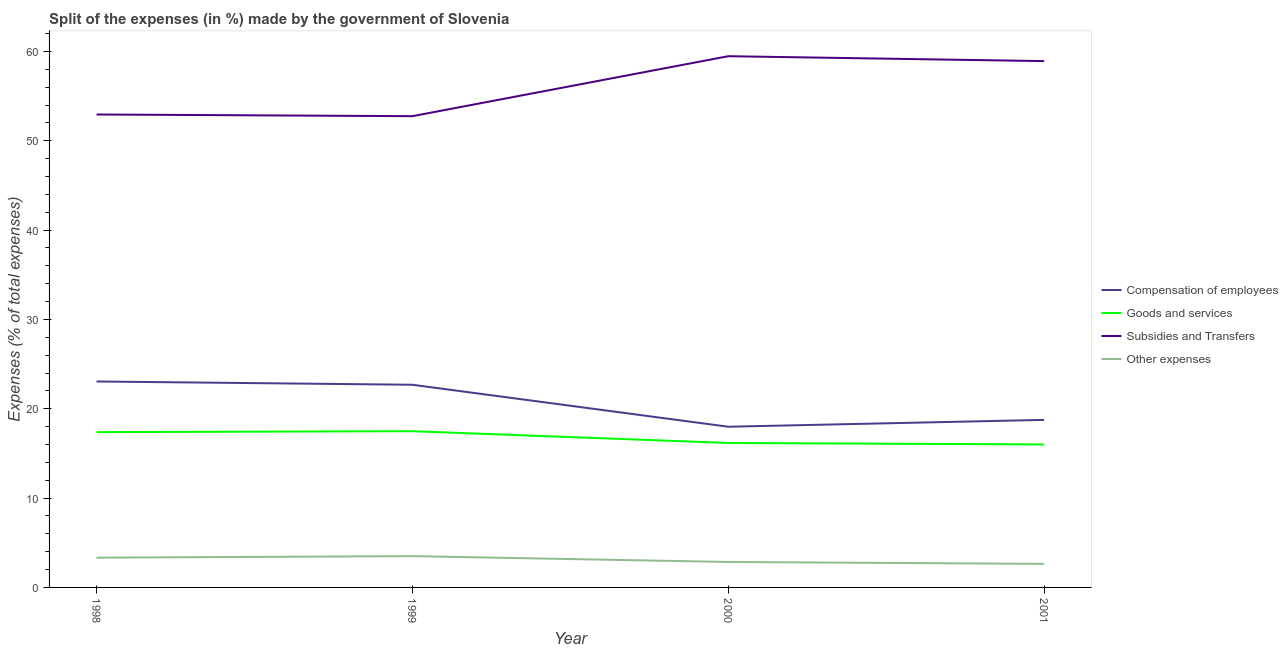How many different coloured lines are there?
Offer a very short reply. 4. Does the line corresponding to percentage of amount spent on goods and services intersect with the line corresponding to percentage of amount spent on other expenses?
Give a very brief answer. No. Is the number of lines equal to the number of legend labels?
Provide a short and direct response. Yes. What is the percentage of amount spent on subsidies in 2000?
Ensure brevity in your answer.  59.47. Across all years, what is the maximum percentage of amount spent on other expenses?
Your response must be concise. 3.5. Across all years, what is the minimum percentage of amount spent on other expenses?
Ensure brevity in your answer.  2.64. In which year was the percentage of amount spent on other expenses maximum?
Make the answer very short. 1999. In which year was the percentage of amount spent on compensation of employees minimum?
Offer a terse response. 2000. What is the total percentage of amount spent on other expenses in the graph?
Give a very brief answer. 12.32. What is the difference between the percentage of amount spent on subsidies in 1998 and that in 2000?
Provide a short and direct response. -6.52. What is the difference between the percentage of amount spent on goods and services in 2001 and the percentage of amount spent on subsidies in 1998?
Give a very brief answer. -36.94. What is the average percentage of amount spent on goods and services per year?
Offer a terse response. 16.76. In the year 2000, what is the difference between the percentage of amount spent on goods and services and percentage of amount spent on other expenses?
Provide a short and direct response. 13.32. What is the ratio of the percentage of amount spent on goods and services in 1998 to that in 2001?
Ensure brevity in your answer.  1.09. Is the percentage of amount spent on subsidies in 1999 less than that in 2000?
Ensure brevity in your answer.  Yes. What is the difference between the highest and the second highest percentage of amount spent on other expenses?
Your answer should be compact. 0.17. What is the difference between the highest and the lowest percentage of amount spent on goods and services?
Your answer should be very brief. 1.49. Is it the case that in every year, the sum of the percentage of amount spent on other expenses and percentage of amount spent on goods and services is greater than the sum of percentage of amount spent on compensation of employees and percentage of amount spent on subsidies?
Your answer should be compact. No. Is the percentage of amount spent on other expenses strictly greater than the percentage of amount spent on goods and services over the years?
Ensure brevity in your answer.  No. Is the percentage of amount spent on goods and services strictly less than the percentage of amount spent on subsidies over the years?
Your answer should be very brief. Yes. How many lines are there?
Give a very brief answer. 4. How many years are there in the graph?
Make the answer very short. 4. Does the graph contain any zero values?
Make the answer very short. No. Where does the legend appear in the graph?
Your answer should be very brief. Center right. How many legend labels are there?
Provide a succinct answer. 4. What is the title of the graph?
Your response must be concise. Split of the expenses (in %) made by the government of Slovenia. Does "France" appear as one of the legend labels in the graph?
Offer a very short reply. No. What is the label or title of the Y-axis?
Keep it short and to the point. Expenses (% of total expenses). What is the Expenses (% of total expenses) of Compensation of employees in 1998?
Make the answer very short. 23.05. What is the Expenses (% of total expenses) in Goods and services in 1998?
Give a very brief answer. 17.38. What is the Expenses (% of total expenses) in Subsidies and Transfers in 1998?
Offer a very short reply. 52.94. What is the Expenses (% of total expenses) in Other expenses in 1998?
Your answer should be very brief. 3.33. What is the Expenses (% of total expenses) of Compensation of employees in 1999?
Offer a very short reply. 22.69. What is the Expenses (% of total expenses) in Goods and services in 1999?
Provide a succinct answer. 17.49. What is the Expenses (% of total expenses) in Subsidies and Transfers in 1999?
Keep it short and to the point. 52.75. What is the Expenses (% of total expenses) of Other expenses in 1999?
Give a very brief answer. 3.5. What is the Expenses (% of total expenses) of Compensation of employees in 2000?
Make the answer very short. 17.99. What is the Expenses (% of total expenses) in Goods and services in 2000?
Your answer should be very brief. 16.17. What is the Expenses (% of total expenses) in Subsidies and Transfers in 2000?
Your response must be concise. 59.47. What is the Expenses (% of total expenses) of Other expenses in 2000?
Your response must be concise. 2.85. What is the Expenses (% of total expenses) in Compensation of employees in 2001?
Provide a short and direct response. 18.76. What is the Expenses (% of total expenses) of Goods and services in 2001?
Provide a short and direct response. 16.01. What is the Expenses (% of total expenses) in Subsidies and Transfers in 2001?
Provide a short and direct response. 58.92. What is the Expenses (% of total expenses) of Other expenses in 2001?
Your answer should be compact. 2.64. Across all years, what is the maximum Expenses (% of total expenses) in Compensation of employees?
Provide a succinct answer. 23.05. Across all years, what is the maximum Expenses (% of total expenses) in Goods and services?
Offer a terse response. 17.49. Across all years, what is the maximum Expenses (% of total expenses) in Subsidies and Transfers?
Your answer should be very brief. 59.47. Across all years, what is the maximum Expenses (% of total expenses) of Other expenses?
Make the answer very short. 3.5. Across all years, what is the minimum Expenses (% of total expenses) in Compensation of employees?
Provide a short and direct response. 17.99. Across all years, what is the minimum Expenses (% of total expenses) in Goods and services?
Your answer should be compact. 16.01. Across all years, what is the minimum Expenses (% of total expenses) in Subsidies and Transfers?
Your answer should be very brief. 52.75. Across all years, what is the minimum Expenses (% of total expenses) of Other expenses?
Your response must be concise. 2.64. What is the total Expenses (% of total expenses) of Compensation of employees in the graph?
Give a very brief answer. 82.49. What is the total Expenses (% of total expenses) in Goods and services in the graph?
Provide a short and direct response. 67.05. What is the total Expenses (% of total expenses) of Subsidies and Transfers in the graph?
Keep it short and to the point. 224.08. What is the total Expenses (% of total expenses) of Other expenses in the graph?
Your answer should be compact. 12.32. What is the difference between the Expenses (% of total expenses) in Compensation of employees in 1998 and that in 1999?
Ensure brevity in your answer.  0.37. What is the difference between the Expenses (% of total expenses) of Goods and services in 1998 and that in 1999?
Ensure brevity in your answer.  -0.11. What is the difference between the Expenses (% of total expenses) of Subsidies and Transfers in 1998 and that in 1999?
Ensure brevity in your answer.  0.19. What is the difference between the Expenses (% of total expenses) of Other expenses in 1998 and that in 1999?
Make the answer very short. -0.17. What is the difference between the Expenses (% of total expenses) of Compensation of employees in 1998 and that in 2000?
Your answer should be compact. 5.07. What is the difference between the Expenses (% of total expenses) of Goods and services in 1998 and that in 2000?
Ensure brevity in your answer.  1.21. What is the difference between the Expenses (% of total expenses) in Subsidies and Transfers in 1998 and that in 2000?
Keep it short and to the point. -6.52. What is the difference between the Expenses (% of total expenses) in Other expenses in 1998 and that in 2000?
Your response must be concise. 0.48. What is the difference between the Expenses (% of total expenses) in Compensation of employees in 1998 and that in 2001?
Your answer should be compact. 4.3. What is the difference between the Expenses (% of total expenses) of Goods and services in 1998 and that in 2001?
Make the answer very short. 1.38. What is the difference between the Expenses (% of total expenses) in Subsidies and Transfers in 1998 and that in 2001?
Offer a terse response. -5.98. What is the difference between the Expenses (% of total expenses) of Other expenses in 1998 and that in 2001?
Ensure brevity in your answer.  0.69. What is the difference between the Expenses (% of total expenses) in Compensation of employees in 1999 and that in 2000?
Provide a short and direct response. 4.7. What is the difference between the Expenses (% of total expenses) in Goods and services in 1999 and that in 2000?
Offer a terse response. 1.32. What is the difference between the Expenses (% of total expenses) in Subsidies and Transfers in 1999 and that in 2000?
Offer a terse response. -6.71. What is the difference between the Expenses (% of total expenses) in Other expenses in 1999 and that in 2000?
Offer a terse response. 0.65. What is the difference between the Expenses (% of total expenses) in Compensation of employees in 1999 and that in 2001?
Keep it short and to the point. 3.93. What is the difference between the Expenses (% of total expenses) of Goods and services in 1999 and that in 2001?
Provide a succinct answer. 1.49. What is the difference between the Expenses (% of total expenses) of Subsidies and Transfers in 1999 and that in 2001?
Keep it short and to the point. -6.16. What is the difference between the Expenses (% of total expenses) of Other expenses in 1999 and that in 2001?
Your answer should be compact. 0.86. What is the difference between the Expenses (% of total expenses) of Compensation of employees in 2000 and that in 2001?
Offer a terse response. -0.77. What is the difference between the Expenses (% of total expenses) of Goods and services in 2000 and that in 2001?
Ensure brevity in your answer.  0.17. What is the difference between the Expenses (% of total expenses) in Subsidies and Transfers in 2000 and that in 2001?
Offer a very short reply. 0.55. What is the difference between the Expenses (% of total expenses) of Other expenses in 2000 and that in 2001?
Ensure brevity in your answer.  0.21. What is the difference between the Expenses (% of total expenses) of Compensation of employees in 1998 and the Expenses (% of total expenses) of Goods and services in 1999?
Give a very brief answer. 5.56. What is the difference between the Expenses (% of total expenses) of Compensation of employees in 1998 and the Expenses (% of total expenses) of Subsidies and Transfers in 1999?
Offer a very short reply. -29.7. What is the difference between the Expenses (% of total expenses) in Compensation of employees in 1998 and the Expenses (% of total expenses) in Other expenses in 1999?
Your response must be concise. 19.55. What is the difference between the Expenses (% of total expenses) in Goods and services in 1998 and the Expenses (% of total expenses) in Subsidies and Transfers in 1999?
Keep it short and to the point. -35.37. What is the difference between the Expenses (% of total expenses) in Goods and services in 1998 and the Expenses (% of total expenses) in Other expenses in 1999?
Your answer should be compact. 13.88. What is the difference between the Expenses (% of total expenses) of Subsidies and Transfers in 1998 and the Expenses (% of total expenses) of Other expenses in 1999?
Your response must be concise. 49.44. What is the difference between the Expenses (% of total expenses) of Compensation of employees in 1998 and the Expenses (% of total expenses) of Goods and services in 2000?
Give a very brief answer. 6.88. What is the difference between the Expenses (% of total expenses) in Compensation of employees in 1998 and the Expenses (% of total expenses) in Subsidies and Transfers in 2000?
Offer a terse response. -36.41. What is the difference between the Expenses (% of total expenses) in Compensation of employees in 1998 and the Expenses (% of total expenses) in Other expenses in 2000?
Give a very brief answer. 20.2. What is the difference between the Expenses (% of total expenses) of Goods and services in 1998 and the Expenses (% of total expenses) of Subsidies and Transfers in 2000?
Make the answer very short. -42.08. What is the difference between the Expenses (% of total expenses) in Goods and services in 1998 and the Expenses (% of total expenses) in Other expenses in 2000?
Provide a succinct answer. 14.53. What is the difference between the Expenses (% of total expenses) of Subsidies and Transfers in 1998 and the Expenses (% of total expenses) of Other expenses in 2000?
Make the answer very short. 50.09. What is the difference between the Expenses (% of total expenses) in Compensation of employees in 1998 and the Expenses (% of total expenses) in Goods and services in 2001?
Your answer should be compact. 7.05. What is the difference between the Expenses (% of total expenses) of Compensation of employees in 1998 and the Expenses (% of total expenses) of Subsidies and Transfers in 2001?
Keep it short and to the point. -35.86. What is the difference between the Expenses (% of total expenses) of Compensation of employees in 1998 and the Expenses (% of total expenses) of Other expenses in 2001?
Your answer should be compact. 20.42. What is the difference between the Expenses (% of total expenses) in Goods and services in 1998 and the Expenses (% of total expenses) in Subsidies and Transfers in 2001?
Offer a very short reply. -41.53. What is the difference between the Expenses (% of total expenses) of Goods and services in 1998 and the Expenses (% of total expenses) of Other expenses in 2001?
Offer a terse response. 14.75. What is the difference between the Expenses (% of total expenses) in Subsidies and Transfers in 1998 and the Expenses (% of total expenses) in Other expenses in 2001?
Provide a succinct answer. 50.3. What is the difference between the Expenses (% of total expenses) of Compensation of employees in 1999 and the Expenses (% of total expenses) of Goods and services in 2000?
Provide a short and direct response. 6.52. What is the difference between the Expenses (% of total expenses) in Compensation of employees in 1999 and the Expenses (% of total expenses) in Subsidies and Transfers in 2000?
Provide a succinct answer. -36.78. What is the difference between the Expenses (% of total expenses) of Compensation of employees in 1999 and the Expenses (% of total expenses) of Other expenses in 2000?
Ensure brevity in your answer.  19.84. What is the difference between the Expenses (% of total expenses) of Goods and services in 1999 and the Expenses (% of total expenses) of Subsidies and Transfers in 2000?
Provide a short and direct response. -41.98. What is the difference between the Expenses (% of total expenses) in Goods and services in 1999 and the Expenses (% of total expenses) in Other expenses in 2000?
Make the answer very short. 14.64. What is the difference between the Expenses (% of total expenses) in Subsidies and Transfers in 1999 and the Expenses (% of total expenses) in Other expenses in 2000?
Give a very brief answer. 49.9. What is the difference between the Expenses (% of total expenses) in Compensation of employees in 1999 and the Expenses (% of total expenses) in Goods and services in 2001?
Offer a terse response. 6.68. What is the difference between the Expenses (% of total expenses) in Compensation of employees in 1999 and the Expenses (% of total expenses) in Subsidies and Transfers in 2001?
Give a very brief answer. -36.23. What is the difference between the Expenses (% of total expenses) of Compensation of employees in 1999 and the Expenses (% of total expenses) of Other expenses in 2001?
Offer a terse response. 20.05. What is the difference between the Expenses (% of total expenses) in Goods and services in 1999 and the Expenses (% of total expenses) in Subsidies and Transfers in 2001?
Your answer should be compact. -41.43. What is the difference between the Expenses (% of total expenses) in Goods and services in 1999 and the Expenses (% of total expenses) in Other expenses in 2001?
Make the answer very short. 14.85. What is the difference between the Expenses (% of total expenses) of Subsidies and Transfers in 1999 and the Expenses (% of total expenses) of Other expenses in 2001?
Make the answer very short. 50.12. What is the difference between the Expenses (% of total expenses) in Compensation of employees in 2000 and the Expenses (% of total expenses) in Goods and services in 2001?
Ensure brevity in your answer.  1.98. What is the difference between the Expenses (% of total expenses) in Compensation of employees in 2000 and the Expenses (% of total expenses) in Subsidies and Transfers in 2001?
Make the answer very short. -40.93. What is the difference between the Expenses (% of total expenses) of Compensation of employees in 2000 and the Expenses (% of total expenses) of Other expenses in 2001?
Keep it short and to the point. 15.35. What is the difference between the Expenses (% of total expenses) in Goods and services in 2000 and the Expenses (% of total expenses) in Subsidies and Transfers in 2001?
Your response must be concise. -42.75. What is the difference between the Expenses (% of total expenses) in Goods and services in 2000 and the Expenses (% of total expenses) in Other expenses in 2001?
Your answer should be very brief. 13.53. What is the difference between the Expenses (% of total expenses) of Subsidies and Transfers in 2000 and the Expenses (% of total expenses) of Other expenses in 2001?
Make the answer very short. 56.83. What is the average Expenses (% of total expenses) of Compensation of employees per year?
Ensure brevity in your answer.  20.62. What is the average Expenses (% of total expenses) of Goods and services per year?
Your answer should be compact. 16.76. What is the average Expenses (% of total expenses) of Subsidies and Transfers per year?
Offer a very short reply. 56.02. What is the average Expenses (% of total expenses) of Other expenses per year?
Keep it short and to the point. 3.08. In the year 1998, what is the difference between the Expenses (% of total expenses) in Compensation of employees and Expenses (% of total expenses) in Goods and services?
Your answer should be compact. 5.67. In the year 1998, what is the difference between the Expenses (% of total expenses) of Compensation of employees and Expenses (% of total expenses) of Subsidies and Transfers?
Your response must be concise. -29.89. In the year 1998, what is the difference between the Expenses (% of total expenses) of Compensation of employees and Expenses (% of total expenses) of Other expenses?
Give a very brief answer. 19.72. In the year 1998, what is the difference between the Expenses (% of total expenses) of Goods and services and Expenses (% of total expenses) of Subsidies and Transfers?
Ensure brevity in your answer.  -35.56. In the year 1998, what is the difference between the Expenses (% of total expenses) of Goods and services and Expenses (% of total expenses) of Other expenses?
Your response must be concise. 14.05. In the year 1998, what is the difference between the Expenses (% of total expenses) in Subsidies and Transfers and Expenses (% of total expenses) in Other expenses?
Give a very brief answer. 49.61. In the year 1999, what is the difference between the Expenses (% of total expenses) in Compensation of employees and Expenses (% of total expenses) in Goods and services?
Give a very brief answer. 5.2. In the year 1999, what is the difference between the Expenses (% of total expenses) in Compensation of employees and Expenses (% of total expenses) in Subsidies and Transfers?
Keep it short and to the point. -30.07. In the year 1999, what is the difference between the Expenses (% of total expenses) of Compensation of employees and Expenses (% of total expenses) of Other expenses?
Make the answer very short. 19.19. In the year 1999, what is the difference between the Expenses (% of total expenses) of Goods and services and Expenses (% of total expenses) of Subsidies and Transfers?
Make the answer very short. -35.26. In the year 1999, what is the difference between the Expenses (% of total expenses) in Goods and services and Expenses (% of total expenses) in Other expenses?
Offer a terse response. 13.99. In the year 1999, what is the difference between the Expenses (% of total expenses) of Subsidies and Transfers and Expenses (% of total expenses) of Other expenses?
Provide a short and direct response. 49.25. In the year 2000, what is the difference between the Expenses (% of total expenses) of Compensation of employees and Expenses (% of total expenses) of Goods and services?
Offer a terse response. 1.82. In the year 2000, what is the difference between the Expenses (% of total expenses) in Compensation of employees and Expenses (% of total expenses) in Subsidies and Transfers?
Make the answer very short. -41.48. In the year 2000, what is the difference between the Expenses (% of total expenses) of Compensation of employees and Expenses (% of total expenses) of Other expenses?
Give a very brief answer. 15.14. In the year 2000, what is the difference between the Expenses (% of total expenses) of Goods and services and Expenses (% of total expenses) of Subsidies and Transfers?
Your response must be concise. -43.3. In the year 2000, what is the difference between the Expenses (% of total expenses) of Goods and services and Expenses (% of total expenses) of Other expenses?
Your response must be concise. 13.32. In the year 2000, what is the difference between the Expenses (% of total expenses) of Subsidies and Transfers and Expenses (% of total expenses) of Other expenses?
Keep it short and to the point. 56.62. In the year 2001, what is the difference between the Expenses (% of total expenses) of Compensation of employees and Expenses (% of total expenses) of Goods and services?
Your response must be concise. 2.75. In the year 2001, what is the difference between the Expenses (% of total expenses) of Compensation of employees and Expenses (% of total expenses) of Subsidies and Transfers?
Provide a succinct answer. -40.16. In the year 2001, what is the difference between the Expenses (% of total expenses) in Compensation of employees and Expenses (% of total expenses) in Other expenses?
Your answer should be very brief. 16.12. In the year 2001, what is the difference between the Expenses (% of total expenses) in Goods and services and Expenses (% of total expenses) in Subsidies and Transfers?
Provide a succinct answer. -42.91. In the year 2001, what is the difference between the Expenses (% of total expenses) in Goods and services and Expenses (% of total expenses) in Other expenses?
Your answer should be compact. 13.37. In the year 2001, what is the difference between the Expenses (% of total expenses) of Subsidies and Transfers and Expenses (% of total expenses) of Other expenses?
Offer a terse response. 56.28. What is the ratio of the Expenses (% of total expenses) in Compensation of employees in 1998 to that in 1999?
Your answer should be compact. 1.02. What is the ratio of the Expenses (% of total expenses) in Goods and services in 1998 to that in 1999?
Keep it short and to the point. 0.99. What is the ratio of the Expenses (% of total expenses) of Subsidies and Transfers in 1998 to that in 1999?
Give a very brief answer. 1. What is the ratio of the Expenses (% of total expenses) in Other expenses in 1998 to that in 1999?
Your response must be concise. 0.95. What is the ratio of the Expenses (% of total expenses) in Compensation of employees in 1998 to that in 2000?
Ensure brevity in your answer.  1.28. What is the ratio of the Expenses (% of total expenses) of Goods and services in 1998 to that in 2000?
Offer a very short reply. 1.08. What is the ratio of the Expenses (% of total expenses) in Subsidies and Transfers in 1998 to that in 2000?
Your answer should be compact. 0.89. What is the ratio of the Expenses (% of total expenses) of Other expenses in 1998 to that in 2000?
Provide a succinct answer. 1.17. What is the ratio of the Expenses (% of total expenses) in Compensation of employees in 1998 to that in 2001?
Ensure brevity in your answer.  1.23. What is the ratio of the Expenses (% of total expenses) of Goods and services in 1998 to that in 2001?
Your answer should be very brief. 1.09. What is the ratio of the Expenses (% of total expenses) in Subsidies and Transfers in 1998 to that in 2001?
Your answer should be compact. 0.9. What is the ratio of the Expenses (% of total expenses) in Other expenses in 1998 to that in 2001?
Provide a succinct answer. 1.26. What is the ratio of the Expenses (% of total expenses) of Compensation of employees in 1999 to that in 2000?
Your answer should be very brief. 1.26. What is the ratio of the Expenses (% of total expenses) in Goods and services in 1999 to that in 2000?
Ensure brevity in your answer.  1.08. What is the ratio of the Expenses (% of total expenses) in Subsidies and Transfers in 1999 to that in 2000?
Ensure brevity in your answer.  0.89. What is the ratio of the Expenses (% of total expenses) of Other expenses in 1999 to that in 2000?
Provide a short and direct response. 1.23. What is the ratio of the Expenses (% of total expenses) of Compensation of employees in 1999 to that in 2001?
Your answer should be very brief. 1.21. What is the ratio of the Expenses (% of total expenses) in Goods and services in 1999 to that in 2001?
Offer a terse response. 1.09. What is the ratio of the Expenses (% of total expenses) in Subsidies and Transfers in 1999 to that in 2001?
Make the answer very short. 0.9. What is the ratio of the Expenses (% of total expenses) of Other expenses in 1999 to that in 2001?
Offer a terse response. 1.33. What is the ratio of the Expenses (% of total expenses) of Compensation of employees in 2000 to that in 2001?
Provide a succinct answer. 0.96. What is the ratio of the Expenses (% of total expenses) of Goods and services in 2000 to that in 2001?
Offer a terse response. 1.01. What is the ratio of the Expenses (% of total expenses) in Subsidies and Transfers in 2000 to that in 2001?
Provide a short and direct response. 1.01. What is the ratio of the Expenses (% of total expenses) in Other expenses in 2000 to that in 2001?
Offer a terse response. 1.08. What is the difference between the highest and the second highest Expenses (% of total expenses) of Compensation of employees?
Your response must be concise. 0.37. What is the difference between the highest and the second highest Expenses (% of total expenses) in Goods and services?
Give a very brief answer. 0.11. What is the difference between the highest and the second highest Expenses (% of total expenses) of Subsidies and Transfers?
Make the answer very short. 0.55. What is the difference between the highest and the second highest Expenses (% of total expenses) in Other expenses?
Your answer should be very brief. 0.17. What is the difference between the highest and the lowest Expenses (% of total expenses) in Compensation of employees?
Your response must be concise. 5.07. What is the difference between the highest and the lowest Expenses (% of total expenses) in Goods and services?
Your response must be concise. 1.49. What is the difference between the highest and the lowest Expenses (% of total expenses) in Subsidies and Transfers?
Your response must be concise. 6.71. What is the difference between the highest and the lowest Expenses (% of total expenses) in Other expenses?
Give a very brief answer. 0.86. 